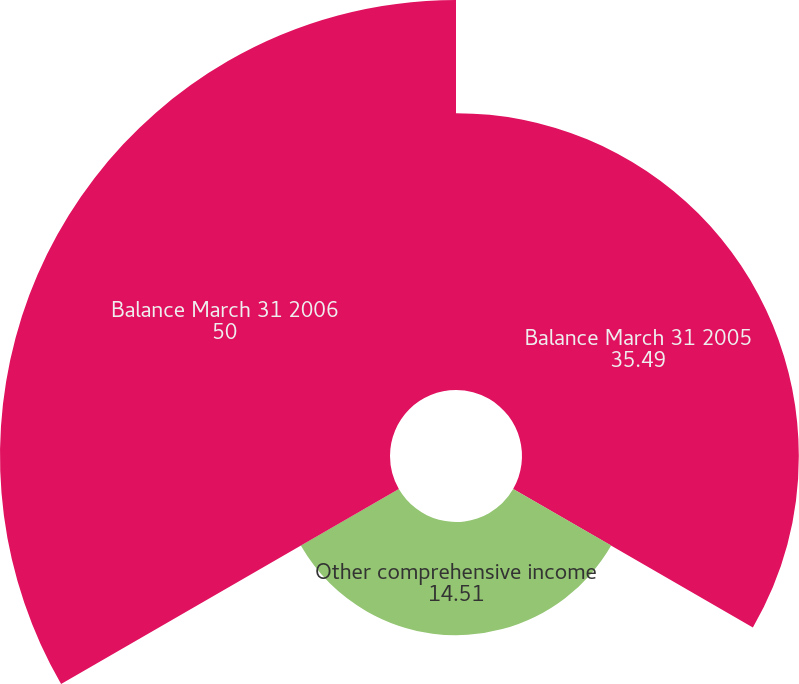<chart> <loc_0><loc_0><loc_500><loc_500><pie_chart><fcel>Balance March 31 2005<fcel>Other comprehensive income<fcel>Balance March 31 2006<nl><fcel>35.49%<fcel>14.51%<fcel>50.0%<nl></chart> 